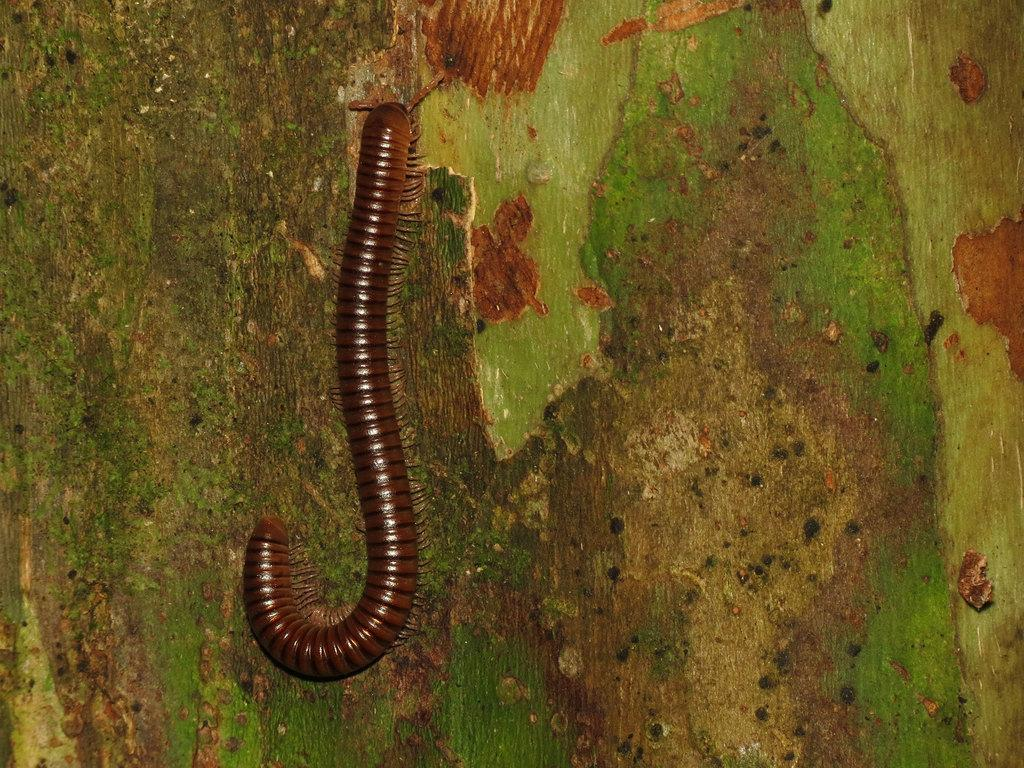What type of surface is visible in the image? There is a wooden surface in the image. What is present on the wooden surface? There is an insect on the wooden surface. How many robins can be seen on the wooden surface in the image? There are no robins present in the image; it only features an insect on the wooden surface. 